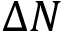<formula> <loc_0><loc_0><loc_500><loc_500>\Delta N</formula> 